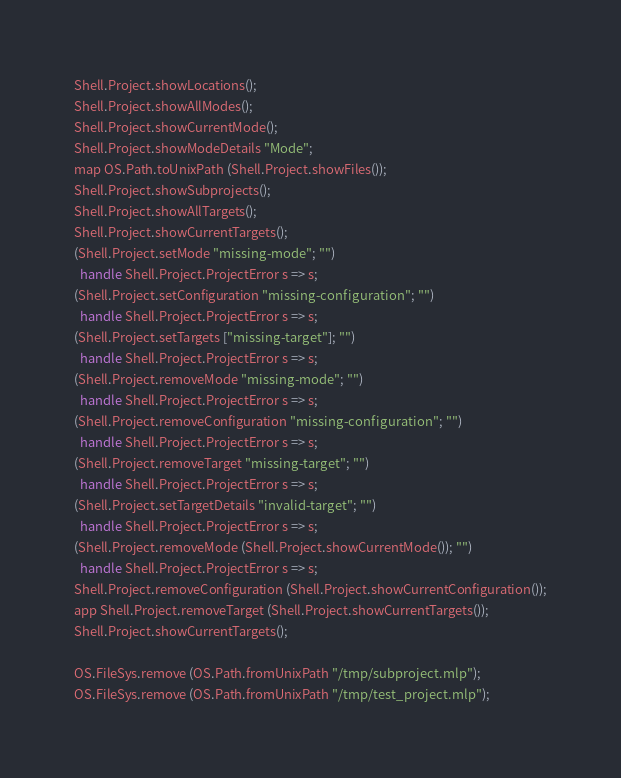<code> <loc_0><loc_0><loc_500><loc_500><_SML_>Shell.Project.showLocations();  
Shell.Project.showAllModes();  
Shell.Project.showCurrentMode();  
Shell.Project.showModeDetails "Mode";  
map OS.Path.toUnixPath (Shell.Project.showFiles());  
Shell.Project.showSubprojects();  
Shell.Project.showAllTargets();  
Shell.Project.showCurrentTargets();  
(Shell.Project.setMode "missing-mode"; "") 
  handle Shell.Project.ProjectError s => s;
(Shell.Project.setConfiguration "missing-configuration"; "") 
  handle Shell.Project.ProjectError s => s;
(Shell.Project.setTargets ["missing-target"]; "") 
  handle Shell.Project.ProjectError s => s;
(Shell.Project.removeMode "missing-mode"; "") 
  handle Shell.Project.ProjectError s => s;
(Shell.Project.removeConfiguration "missing-configuration"; "") 
  handle Shell.Project.ProjectError s => s;
(Shell.Project.removeTarget "missing-target"; "") 
  handle Shell.Project.ProjectError s => s;
(Shell.Project.setTargetDetails "invalid-target"; "")
  handle Shell.Project.ProjectError s => s;
(Shell.Project.removeMode (Shell.Project.showCurrentMode()); "")
  handle Shell.Project.ProjectError s => s;
Shell.Project.removeConfiguration (Shell.Project.showCurrentConfiguration());
app Shell.Project.removeTarget (Shell.Project.showCurrentTargets());
Shell.Project.showCurrentTargets();  

OS.FileSys.remove (OS.Path.fromUnixPath "/tmp/subproject.mlp");
OS.FileSys.remove (OS.Path.fromUnixPath "/tmp/test_project.mlp");



</code> 